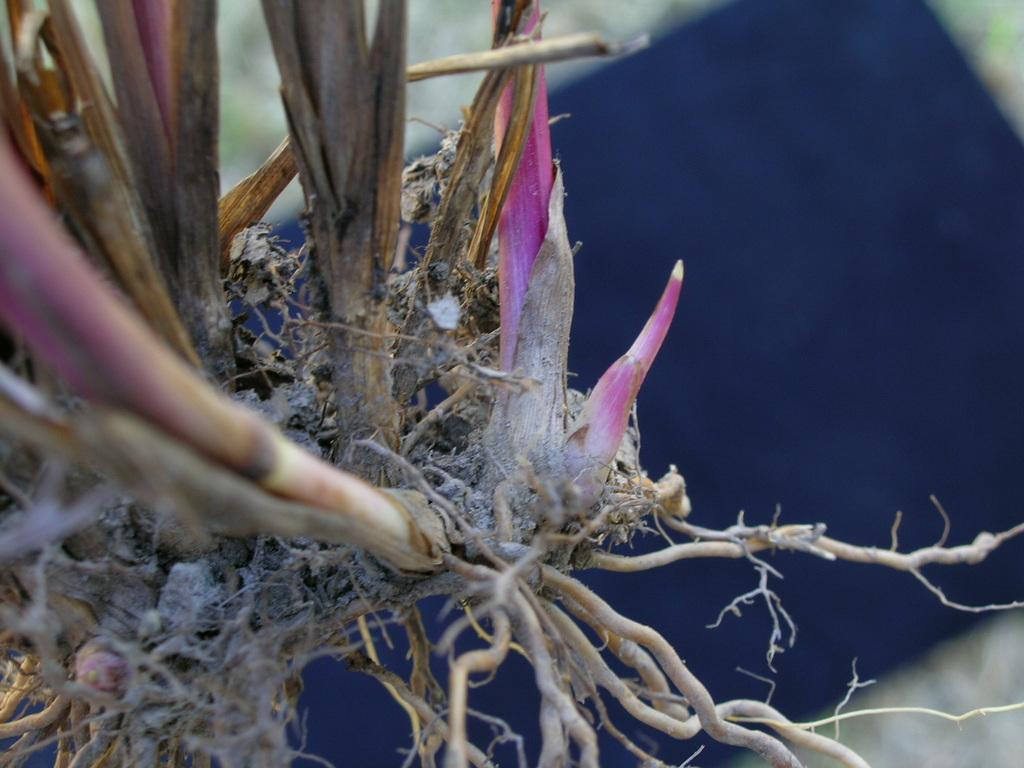What is present in the image? There is a plant in the image. Can you describe the plant's features? The plant has roots and pink color buds. How would you characterize the background of the image? The background of the image is blurry. What is the aftermath of the ice planting in the image? There is no ice planting in the image, and therefore no aftermath can be observed. Can you describe how the plant is pulling nutrients from the soil in the image? The image does not show the plant's roots interacting with the soil, so it cannot be determined how the plant is pulling nutrients. 